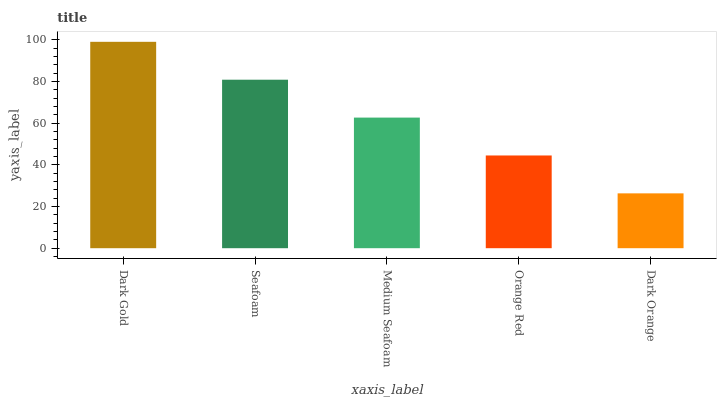Is Dark Orange the minimum?
Answer yes or no. Yes. Is Dark Gold the maximum?
Answer yes or no. Yes. Is Seafoam the minimum?
Answer yes or no. No. Is Seafoam the maximum?
Answer yes or no. No. Is Dark Gold greater than Seafoam?
Answer yes or no. Yes. Is Seafoam less than Dark Gold?
Answer yes or no. Yes. Is Seafoam greater than Dark Gold?
Answer yes or no. No. Is Dark Gold less than Seafoam?
Answer yes or no. No. Is Medium Seafoam the high median?
Answer yes or no. Yes. Is Medium Seafoam the low median?
Answer yes or no. Yes. Is Seafoam the high median?
Answer yes or no. No. Is Orange Red the low median?
Answer yes or no. No. 